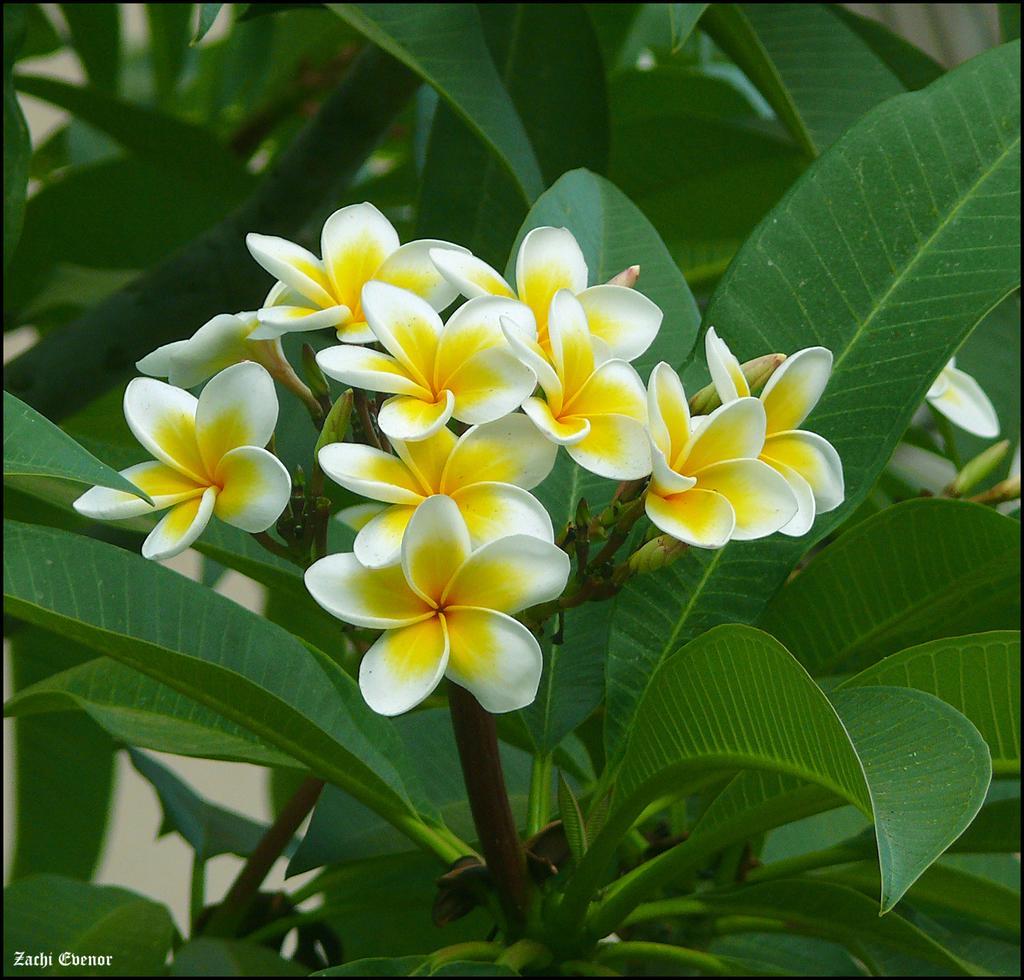Please provide a concise description of this image. In this image, we can see some plants and flowers. We can also see some text on the bottom left corner. 